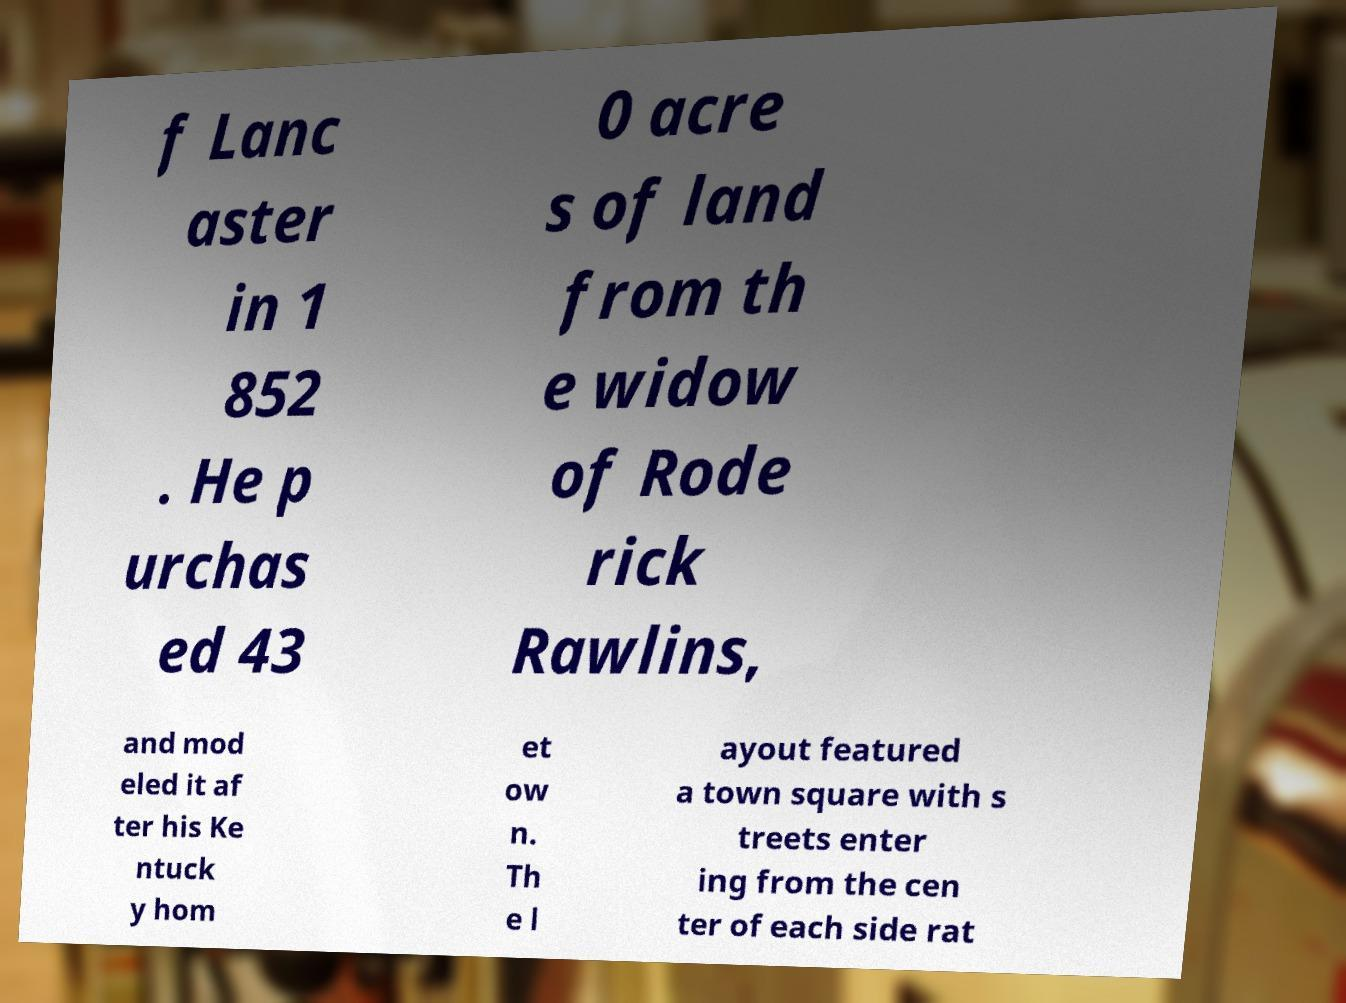Can you read and provide the text displayed in the image?This photo seems to have some interesting text. Can you extract and type it out for me? f Lanc aster in 1 852 . He p urchas ed 43 0 acre s of land from th e widow of Rode rick Rawlins, and mod eled it af ter his Ke ntuck y hom et ow n. Th e l ayout featured a town square with s treets enter ing from the cen ter of each side rat 